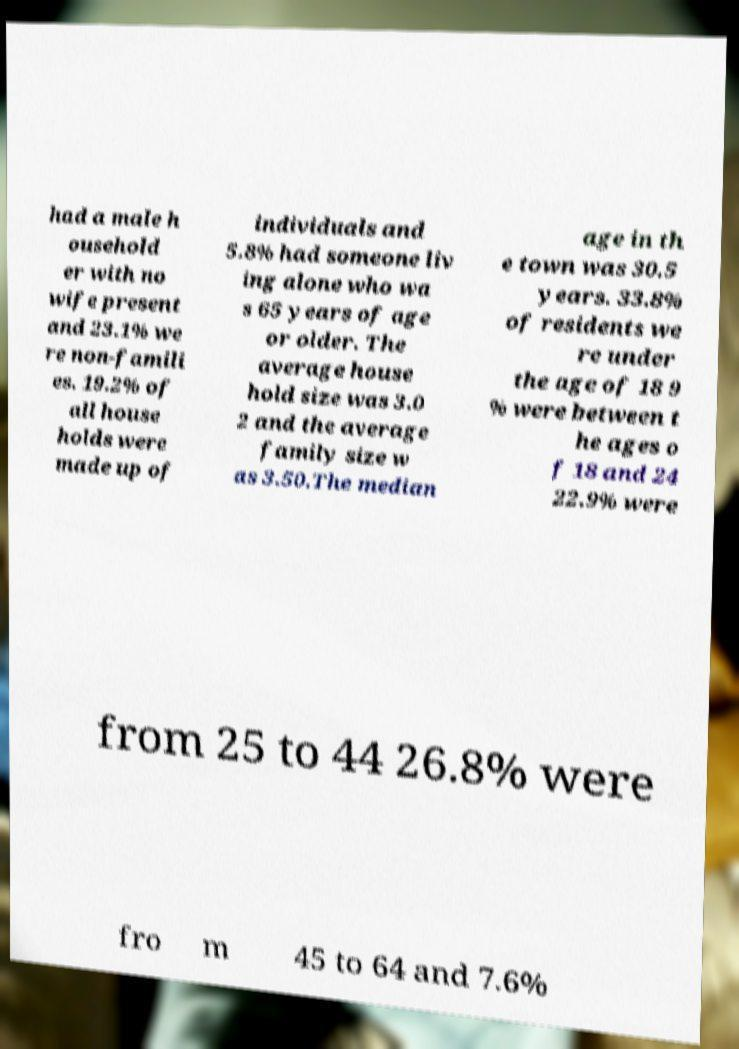I need the written content from this picture converted into text. Can you do that? had a male h ousehold er with no wife present and 23.1% we re non-famili es. 19.2% of all house holds were made up of individuals and 5.8% had someone liv ing alone who wa s 65 years of age or older. The average house hold size was 3.0 2 and the average family size w as 3.50.The median age in th e town was 30.5 years. 33.8% of residents we re under the age of 18 9 % were between t he ages o f 18 and 24 22.9% were from 25 to 44 26.8% were fro m 45 to 64 and 7.6% 